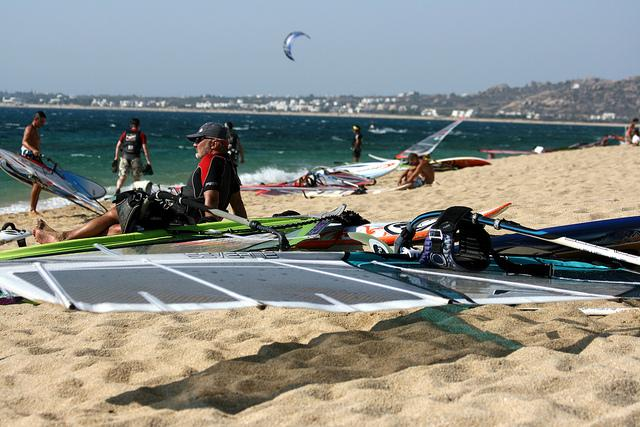Where is the person holding the sail seen here standing? Please explain your reasoning. ocean. The sail is connected to a surf boarder consistent with the activity being displayed. while being used as intended, the person would then be in answer a. 